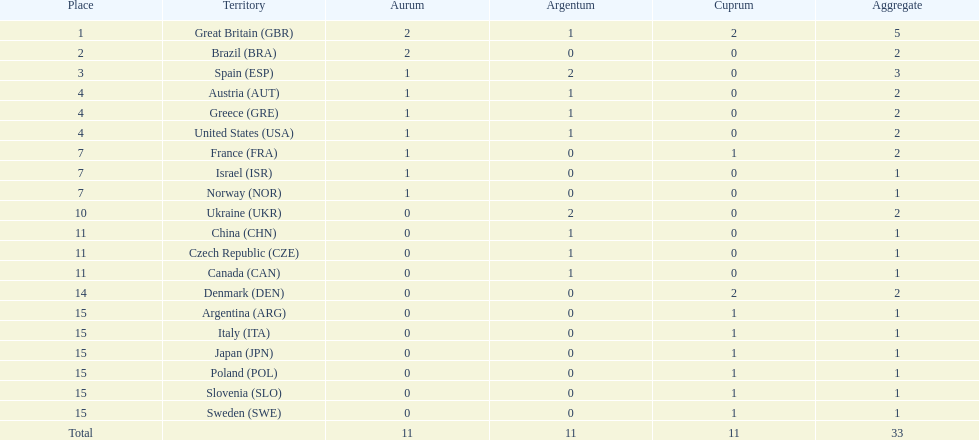Which country won the most medals total? Great Britain (GBR). 